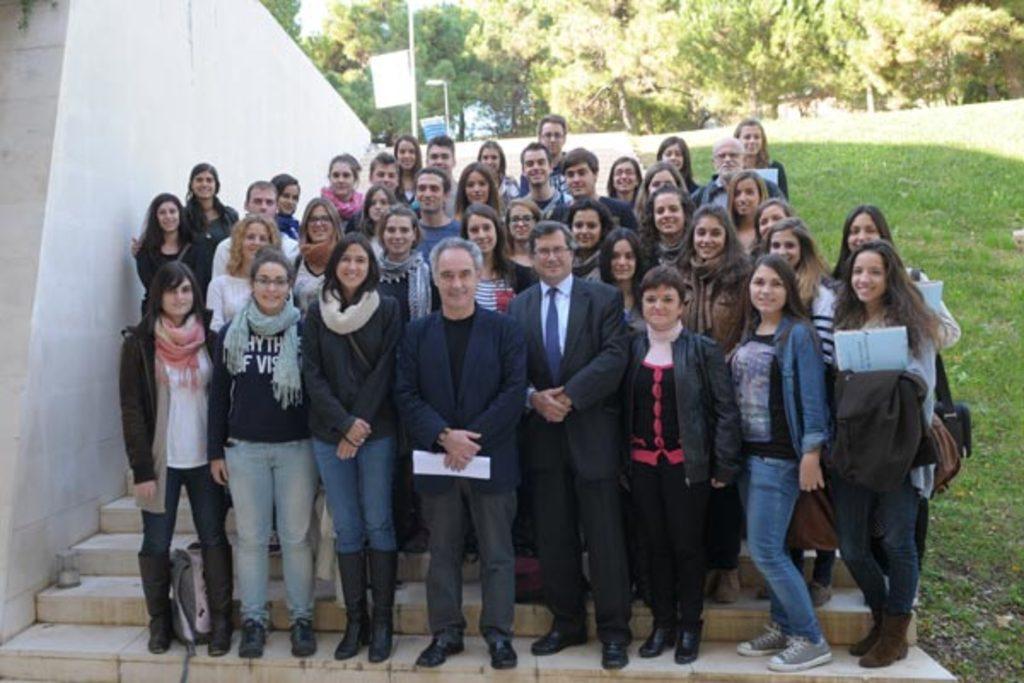Could you give a brief overview of what you see in this image? There are group of people standing and this man holding papers. We can see grass,steps and wall. In the background we can see trees,boards and lights on poles. 